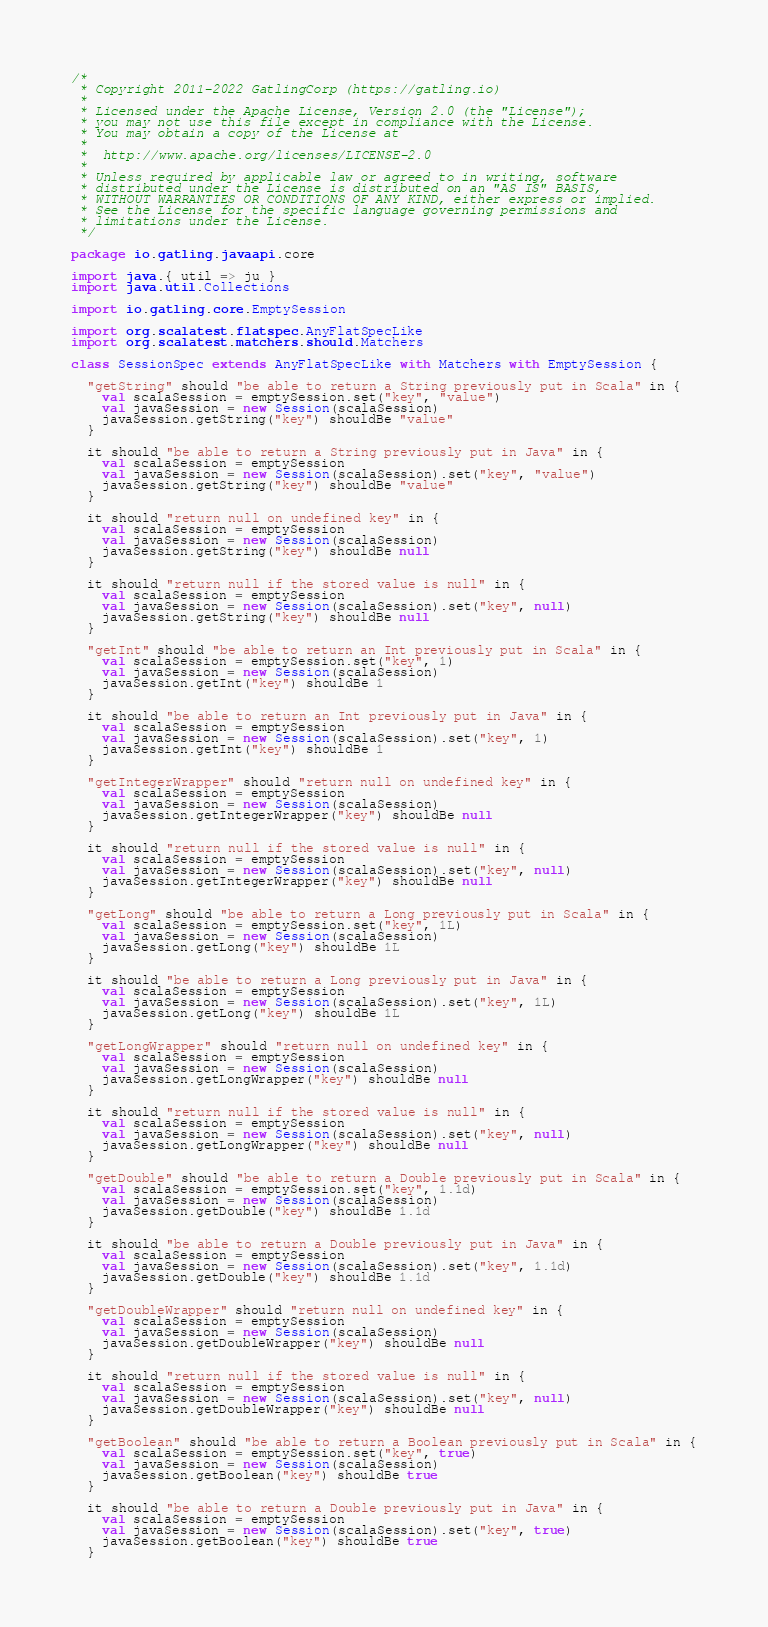<code> <loc_0><loc_0><loc_500><loc_500><_Scala_>/*
 * Copyright 2011-2022 GatlingCorp (https://gatling.io)
 *
 * Licensed under the Apache License, Version 2.0 (the "License");
 * you may not use this file except in compliance with the License.
 * You may obtain a copy of the License at
 *
 *  http://www.apache.org/licenses/LICENSE-2.0
 *
 * Unless required by applicable law or agreed to in writing, software
 * distributed under the License is distributed on an "AS IS" BASIS,
 * WITHOUT WARRANTIES OR CONDITIONS OF ANY KIND, either express or implied.
 * See the License for the specific language governing permissions and
 * limitations under the License.
 */

package io.gatling.javaapi.core

import java.{ util => ju }
import java.util.Collections

import io.gatling.core.EmptySession

import org.scalatest.flatspec.AnyFlatSpecLike
import org.scalatest.matchers.should.Matchers

class SessionSpec extends AnyFlatSpecLike with Matchers with EmptySession {

  "getString" should "be able to return a String previously put in Scala" in {
    val scalaSession = emptySession.set("key", "value")
    val javaSession = new Session(scalaSession)
    javaSession.getString("key") shouldBe "value"
  }

  it should "be able to return a String previously put in Java" in {
    val scalaSession = emptySession
    val javaSession = new Session(scalaSession).set("key", "value")
    javaSession.getString("key") shouldBe "value"
  }

  it should "return null on undefined key" in {
    val scalaSession = emptySession
    val javaSession = new Session(scalaSession)
    javaSession.getString("key") shouldBe null
  }

  it should "return null if the stored value is null" in {
    val scalaSession = emptySession
    val javaSession = new Session(scalaSession).set("key", null)
    javaSession.getString("key") shouldBe null
  }

  "getInt" should "be able to return an Int previously put in Scala" in {
    val scalaSession = emptySession.set("key", 1)
    val javaSession = new Session(scalaSession)
    javaSession.getInt("key") shouldBe 1
  }

  it should "be able to return an Int previously put in Java" in {
    val scalaSession = emptySession
    val javaSession = new Session(scalaSession).set("key", 1)
    javaSession.getInt("key") shouldBe 1
  }

  "getIntegerWrapper" should "return null on undefined key" in {
    val scalaSession = emptySession
    val javaSession = new Session(scalaSession)
    javaSession.getIntegerWrapper("key") shouldBe null
  }

  it should "return null if the stored value is null" in {
    val scalaSession = emptySession
    val javaSession = new Session(scalaSession).set("key", null)
    javaSession.getIntegerWrapper("key") shouldBe null
  }

  "getLong" should "be able to return a Long previously put in Scala" in {
    val scalaSession = emptySession.set("key", 1L)
    val javaSession = new Session(scalaSession)
    javaSession.getLong("key") shouldBe 1L
  }

  it should "be able to return a Long previously put in Java" in {
    val scalaSession = emptySession
    val javaSession = new Session(scalaSession).set("key", 1L)
    javaSession.getLong("key") shouldBe 1L
  }

  "getLongWrapper" should "return null on undefined key" in {
    val scalaSession = emptySession
    val javaSession = new Session(scalaSession)
    javaSession.getLongWrapper("key") shouldBe null
  }

  it should "return null if the stored value is null" in {
    val scalaSession = emptySession
    val javaSession = new Session(scalaSession).set("key", null)
    javaSession.getLongWrapper("key") shouldBe null
  }

  "getDouble" should "be able to return a Double previously put in Scala" in {
    val scalaSession = emptySession.set("key", 1.1d)
    val javaSession = new Session(scalaSession)
    javaSession.getDouble("key") shouldBe 1.1d
  }

  it should "be able to return a Double previously put in Java" in {
    val scalaSession = emptySession
    val javaSession = new Session(scalaSession).set("key", 1.1d)
    javaSession.getDouble("key") shouldBe 1.1d
  }

  "getDoubleWrapper" should "return null on undefined key" in {
    val scalaSession = emptySession
    val javaSession = new Session(scalaSession)
    javaSession.getDoubleWrapper("key") shouldBe null
  }

  it should "return null if the stored value is null" in {
    val scalaSession = emptySession
    val javaSession = new Session(scalaSession).set("key", null)
    javaSession.getDoubleWrapper("key") shouldBe null
  }

  "getBoolean" should "be able to return a Boolean previously put in Scala" in {
    val scalaSession = emptySession.set("key", true)
    val javaSession = new Session(scalaSession)
    javaSession.getBoolean("key") shouldBe true
  }

  it should "be able to return a Double previously put in Java" in {
    val scalaSession = emptySession
    val javaSession = new Session(scalaSession).set("key", true)
    javaSession.getBoolean("key") shouldBe true
  }
</code> 